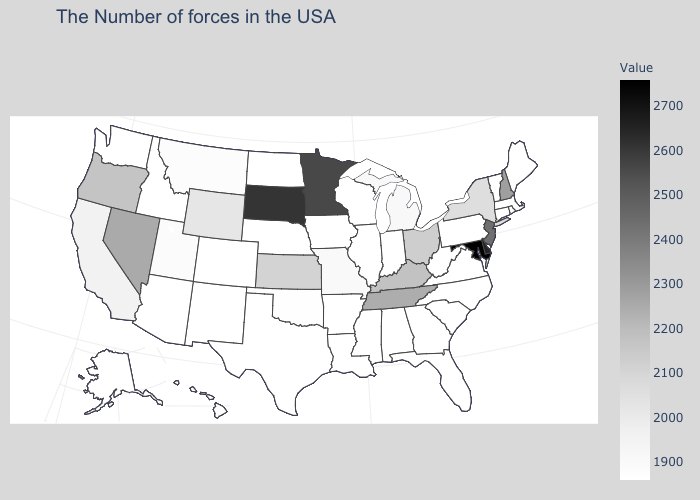Among the states that border Georgia , which have the highest value?
Short answer required. Tennessee. Which states have the highest value in the USA?
Concise answer only. Maryland. Which states hav the highest value in the West?
Give a very brief answer. Nevada. Which states hav the highest value in the MidWest?
Quick response, please. South Dakota. Does Delaware have the lowest value in the South?
Short answer required. No. Which states have the lowest value in the USA?
Be succinct. Maine, Massachusetts, Rhode Island, Vermont, Connecticut, Pennsylvania, Virginia, North Carolina, South Carolina, West Virginia, Florida, Georgia, Indiana, Alabama, Wisconsin, Illinois, Mississippi, Louisiana, Arkansas, Iowa, Nebraska, Texas, North Dakota, Colorado, New Mexico, Arizona, Idaho, Washington, Alaska, Hawaii. Among the states that border Illinois , does Indiana have the lowest value?
Answer briefly. Yes. Among the states that border Kansas , which have the highest value?
Write a very short answer. Missouri. 